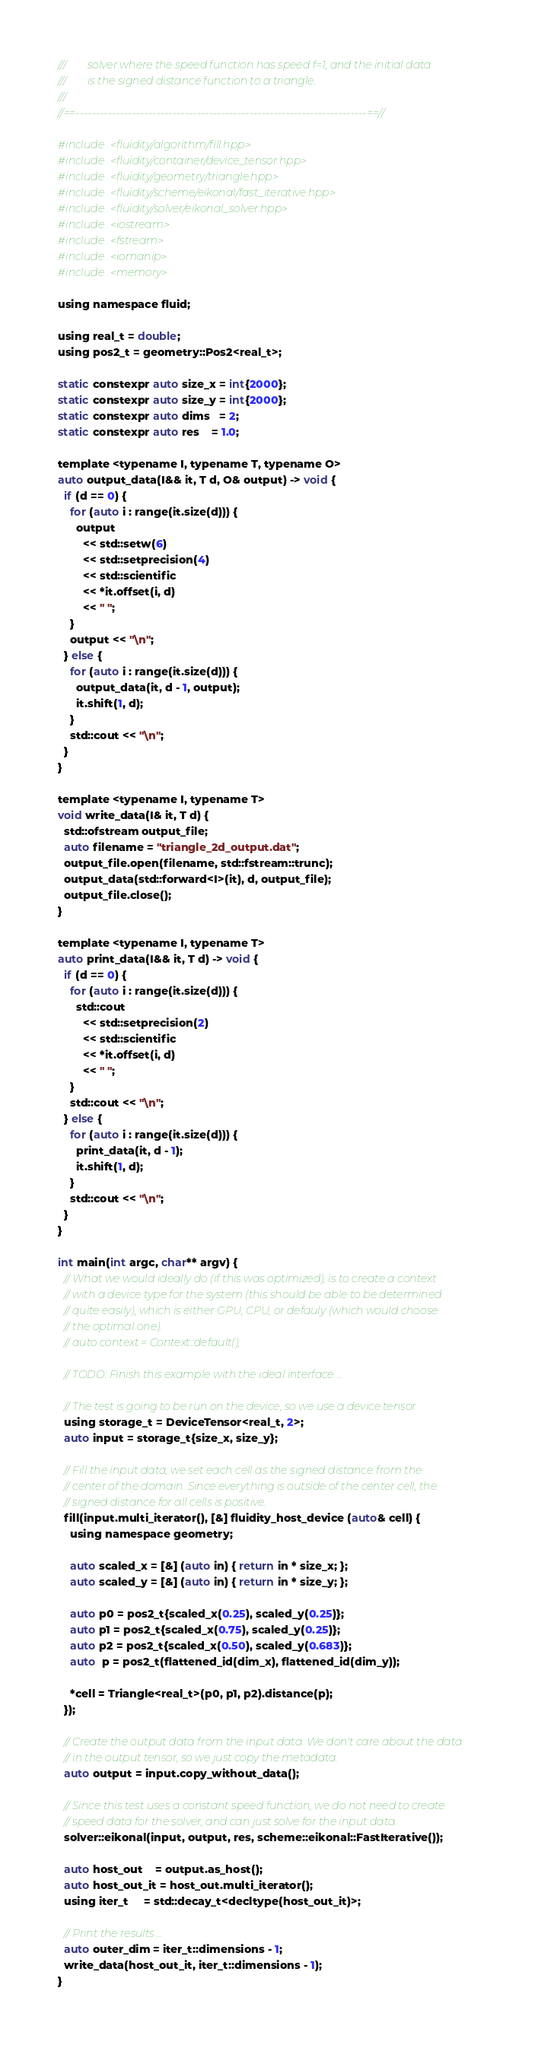<code> <loc_0><loc_0><loc_500><loc_500><_Cuda_>///        solver where the speed function has speed f=1, and the initial data
///        is the signed distance function to a triangle.
///
//==------------------------------------------------------------------------==//

#include <fluidity/algorithm/fill.hpp>
#include <fluidity/container/device_tensor.hpp>
#include <fluidity/geometry/triangle.hpp>
#include <fluidity/scheme/eikonal/fast_iterative.hpp>
#include <fluidity/solver/eikonal_solver.hpp>
#include <iostream>
#include <fstream>
#include <iomanip>
#include <memory>

using namespace fluid;

using real_t = double;
using pos2_t = geometry::Pos2<real_t>;

static constexpr auto size_x = int{2000};
static constexpr auto size_y = int{2000};
static constexpr auto dims   = 2;
static constexpr auto res    = 1.0;

template <typename I, typename T, typename O>
auto output_data(I&& it, T d, O& output) -> void {
  if (d == 0) {
    for (auto i : range(it.size(d))) {
      output
        << std::setw(6)
        << std::setprecision(4)
        << std::scientific
        << *it.offset(i, d)
        << " ";
    }
    output << "\n";
  } else {
    for (auto i : range(it.size(d))) {
      output_data(it, d - 1, output);
      it.shift(1, d);
    }
    std::cout << "\n";
  }
}

template <typename I, typename T>
void write_data(I& it, T d) {
  std::ofstream output_file;
  auto filename = "triangle_2d_output.dat";
  output_file.open(filename, std::fstream::trunc);
  output_data(std::forward<I>(it), d, output_file);
  output_file.close();
}

template <typename I, typename T>
auto print_data(I&& it, T d) -> void {
  if (d == 0) {
    for (auto i : range(it.size(d))) {
      std::cout
        << std::setprecision(2)
        << std::scientific
        << *it.offset(i, d)
        << " ";
    }
    std::cout << "\n";
  } else {
    for (auto i : range(it.size(d))) {
      print_data(it, d - 1);
      it.shift(1, d);
    }
    std::cout << "\n";
  }
}

int main(int argc, char** argv) {
  // What we would ideally do (if this was optimized), is to create a context
  // with a device type for the system (this should be able to be determined
  // quite easily), which is either GPU, CPU, or defauly (which would choose
  // the optimal one).
  // auto context = Context::default();
  
  // TODO: Finish this example with the ideal interface ...

  // The test is going to be run on the device, so we use a device tensor.
  using storage_t = DeviceTensor<real_t, 2>;
  auto input = storage_t{size_x, size_y};

  // Fill the input data, we set each cell as the signed distance from the
  // center of the domain. Since everything is outside of the center cell, the
  // signed distance for all cells is positive.
  fill(input.multi_iterator(), [&] fluidity_host_device (auto& cell) {
    using namespace geometry;

    auto scaled_x = [&] (auto in) { return in * size_x; };
    auto scaled_y = [&] (auto in) { return in * size_y; };

    auto p0 = pos2_t{scaled_x(0.25), scaled_y(0.25)};
    auto p1 = pos2_t{scaled_x(0.75), scaled_y(0.25)};
    auto p2 = pos2_t{scaled_x(0.50), scaled_y(0.683)};
    auto  p = pos2_t(flattened_id(dim_x), flattened_id(dim_y));

    *cell = Triangle<real_t>(p0, p1, p2).distance(p);
  });

  // Create the output data from the input data. We don't care about the data
  // in the output tensor, so we just copy the metadata.
  auto output = input.copy_without_data();

  // Since this test uses a constant speed function, we do not need to create
  // speed data for the solver, and can just solve for the input data.
  solver::eikonal(input, output, res, scheme::eikonal::FastIterative());

  auto host_out    = output.as_host();
  auto host_out_it = host_out.multi_iterator();
  using iter_t     = std::decay_t<decltype(host_out_it)>;

  // Print the results ...
  auto outer_dim = iter_t::dimensions - 1;
  write_data(host_out_it, iter_t::dimensions - 1);
}
</code> 